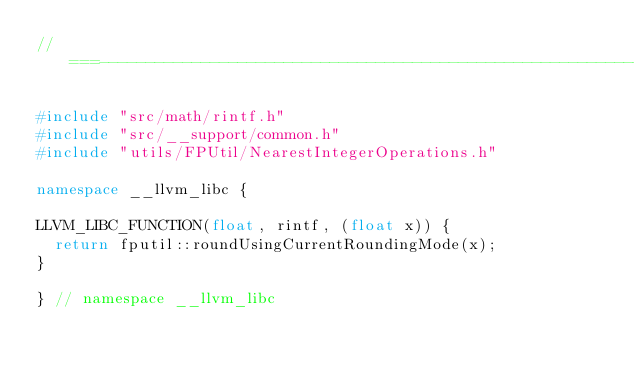Convert code to text. <code><loc_0><loc_0><loc_500><loc_500><_C++_>//===----------------------------------------------------------------------===//

#include "src/math/rintf.h"
#include "src/__support/common.h"
#include "utils/FPUtil/NearestIntegerOperations.h"

namespace __llvm_libc {

LLVM_LIBC_FUNCTION(float, rintf, (float x)) {
  return fputil::roundUsingCurrentRoundingMode(x);
}

} // namespace __llvm_libc
</code> 